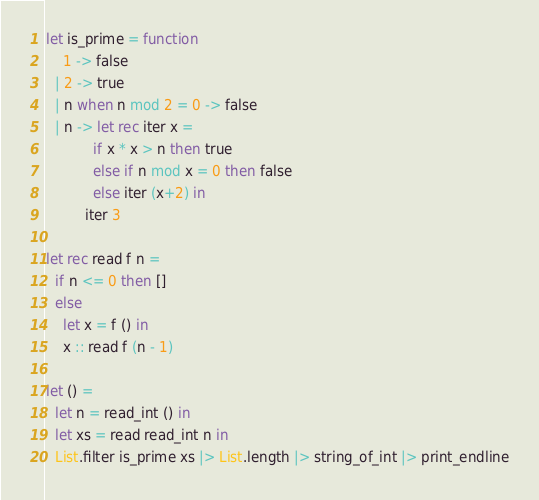<code> <loc_0><loc_0><loc_500><loc_500><_OCaml_>let is_prime = function
    1 -> false
  | 2 -> true
  | n when n mod 2 = 0 -> false
  | n -> let rec iter x =
           if x * x > n then true
           else if n mod x = 0 then false
           else iter (x+2) in
         iter 3
  
let rec read f n =
  if n <= 0 then []
  else
    let x = f () in
    x :: read f (n - 1)

let () =
  let n = read_int () in
  let xs = read read_int n in
  List.filter is_prime xs |> List.length |> string_of_int |> print_endline</code> 